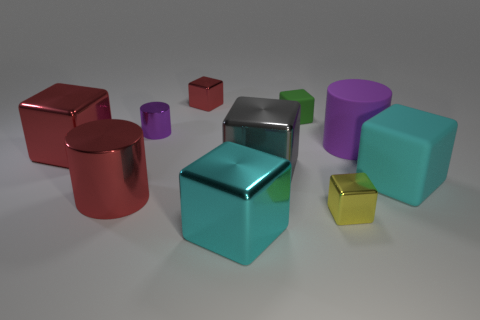Subtract all blue cylinders. How many cyan cubes are left? 2 Subtract all purple cylinders. How many cylinders are left? 1 Subtract all green cubes. How many cubes are left? 6 Subtract 1 cylinders. How many cylinders are left? 2 Subtract all cylinders. How many objects are left? 7 Add 5 cyan objects. How many cyan objects exist? 7 Subtract 0 brown cylinders. How many objects are left? 10 Subtract all green cylinders. Subtract all brown blocks. How many cylinders are left? 3 Subtract all rubber objects. Subtract all large gray rubber cubes. How many objects are left? 7 Add 4 big red cubes. How many big red cubes are left? 5 